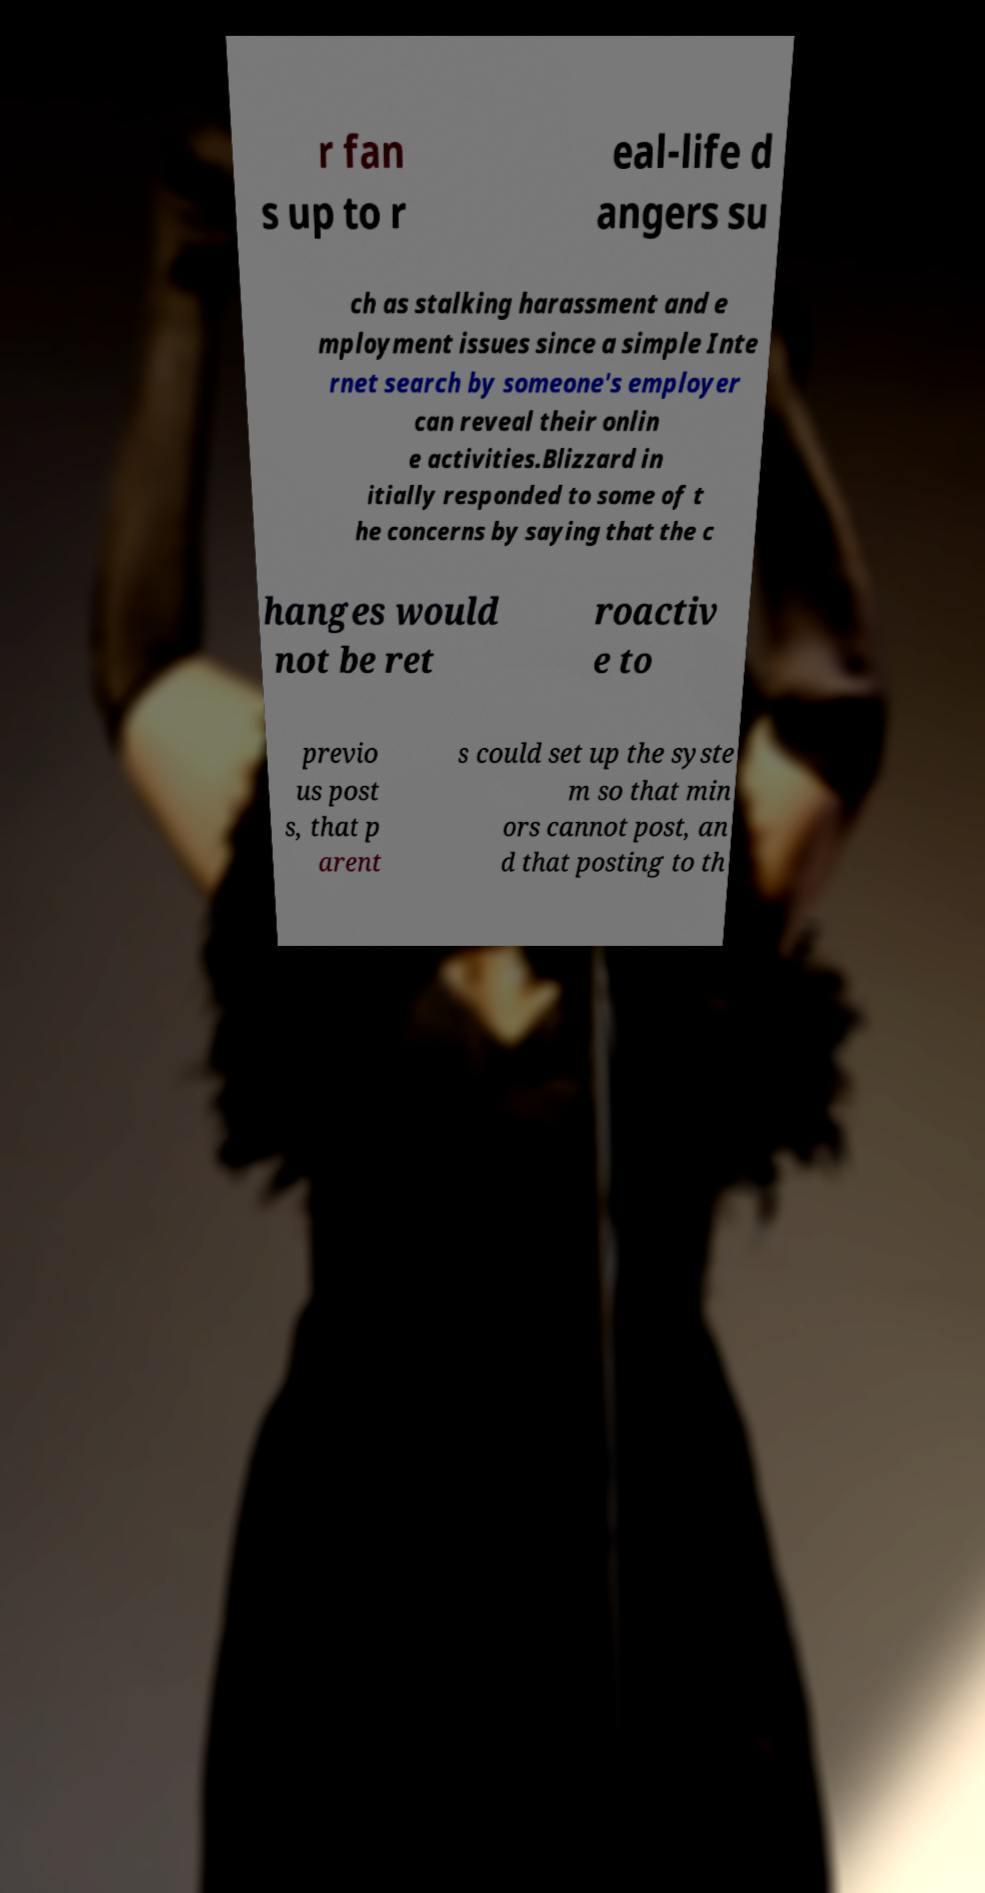Could you extract and type out the text from this image? r fan s up to r eal-life d angers su ch as stalking harassment and e mployment issues since a simple Inte rnet search by someone's employer can reveal their onlin e activities.Blizzard in itially responded to some of t he concerns by saying that the c hanges would not be ret roactiv e to previo us post s, that p arent s could set up the syste m so that min ors cannot post, an d that posting to th 